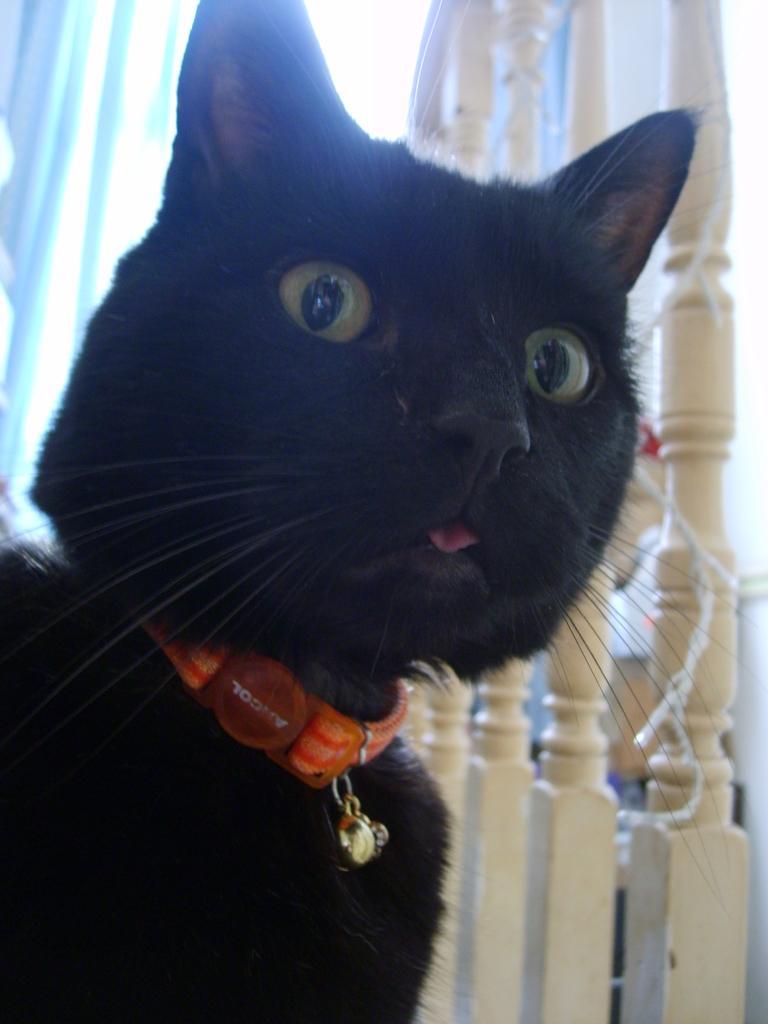In one or two sentences, can you explain what this image depicts? On the left we can see a black cat and there is a belt to its neck and in the background we can see wooden poles,wall,curtain and some other objects. 